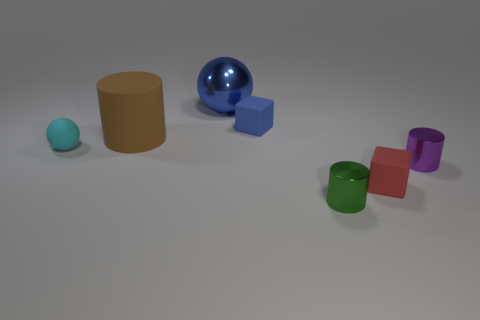Add 2 small purple objects. How many objects exist? 9 Subtract all cylinders. How many objects are left? 4 Add 6 small metallic cylinders. How many small metallic cylinders are left? 8 Add 6 small gray metallic cylinders. How many small gray metallic cylinders exist? 6 Subtract 1 blue cubes. How many objects are left? 6 Subtract all small spheres. Subtract all red blocks. How many objects are left? 5 